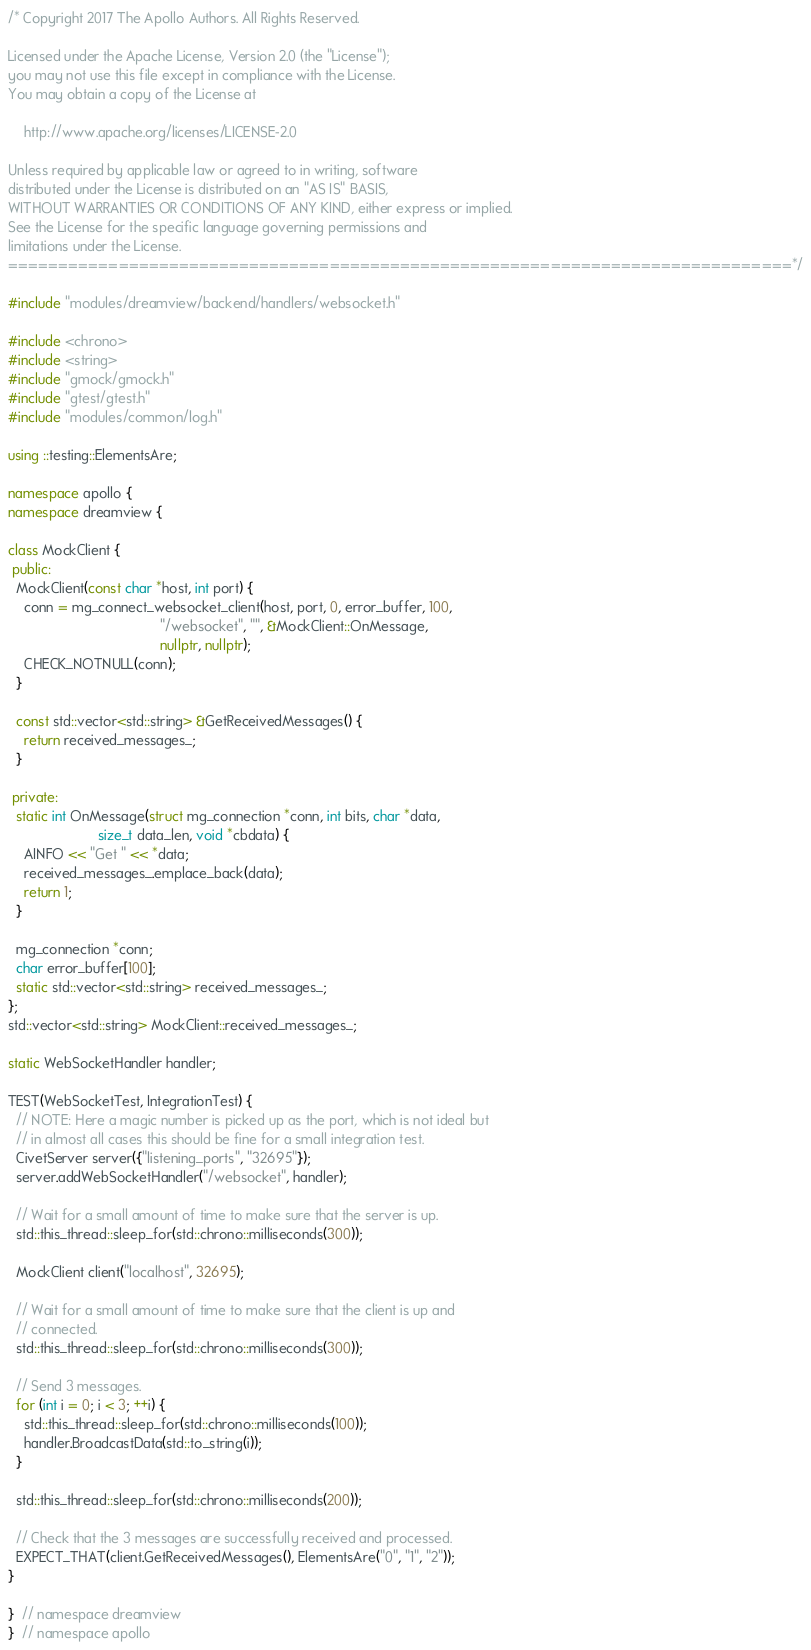<code> <loc_0><loc_0><loc_500><loc_500><_C++_>/* Copyright 2017 The Apollo Authors. All Rights Reserved.

Licensed under the Apache License, Version 2.0 (the "License");
you may not use this file except in compliance with the License.
You may obtain a copy of the License at

    http://www.apache.org/licenses/LICENSE-2.0

Unless required by applicable law or agreed to in writing, software
distributed under the License is distributed on an "AS IS" BASIS,
WITHOUT WARRANTIES OR CONDITIONS OF ANY KIND, either express or implied.
See the License for the specific language governing permissions and
limitations under the License.
==============================================================================*/

#include "modules/dreamview/backend/handlers/websocket.h"

#include <chrono>
#include <string>
#include "gmock/gmock.h"
#include "gtest/gtest.h"
#include "modules/common/log.h"

using ::testing::ElementsAre;

namespace apollo {
namespace dreamview {

class MockClient {
 public:
  MockClient(const char *host, int port) {
    conn = mg_connect_websocket_client(host, port, 0, error_buffer, 100,
                                       "/websocket", "", &MockClient::OnMessage,
                                       nullptr, nullptr);
    CHECK_NOTNULL(conn);
  }

  const std::vector<std::string> &GetReceivedMessages() {
    return received_messages_;
  }

 private:
  static int OnMessage(struct mg_connection *conn, int bits, char *data,
                       size_t data_len, void *cbdata) {
    AINFO << "Get " << *data;
    received_messages_.emplace_back(data);
    return 1;
  }

  mg_connection *conn;
  char error_buffer[100];
  static std::vector<std::string> received_messages_;
};
std::vector<std::string> MockClient::received_messages_;

static WebSocketHandler handler;

TEST(WebSocketTest, IntegrationTest) {
  // NOTE: Here a magic number is picked up as the port, which is not ideal but
  // in almost all cases this should be fine for a small integration test.
  CivetServer server({"listening_ports", "32695"});
  server.addWebSocketHandler("/websocket", handler);

  // Wait for a small amount of time to make sure that the server is up.
  std::this_thread::sleep_for(std::chrono::milliseconds(300));

  MockClient client("localhost", 32695);

  // Wait for a small amount of time to make sure that the client is up and
  // connected.
  std::this_thread::sleep_for(std::chrono::milliseconds(300));

  // Send 3 messages.
  for (int i = 0; i < 3; ++i) {
    std::this_thread::sleep_for(std::chrono::milliseconds(100));
    handler.BroadcastData(std::to_string(i));
  }

  std::this_thread::sleep_for(std::chrono::milliseconds(200));

  // Check that the 3 messages are successfully received and processed.
  EXPECT_THAT(client.GetReceivedMessages(), ElementsAre("0", "1", "2"));
}

}  // namespace dreamview
}  // namespace apollo
</code> 